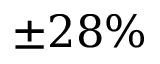<formula> <loc_0><loc_0><loc_500><loc_500>\pm 2 8 \%</formula> 